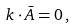<formula> <loc_0><loc_0><loc_500><loc_500>k \cdot \bar { A } = 0 \, ,</formula> 